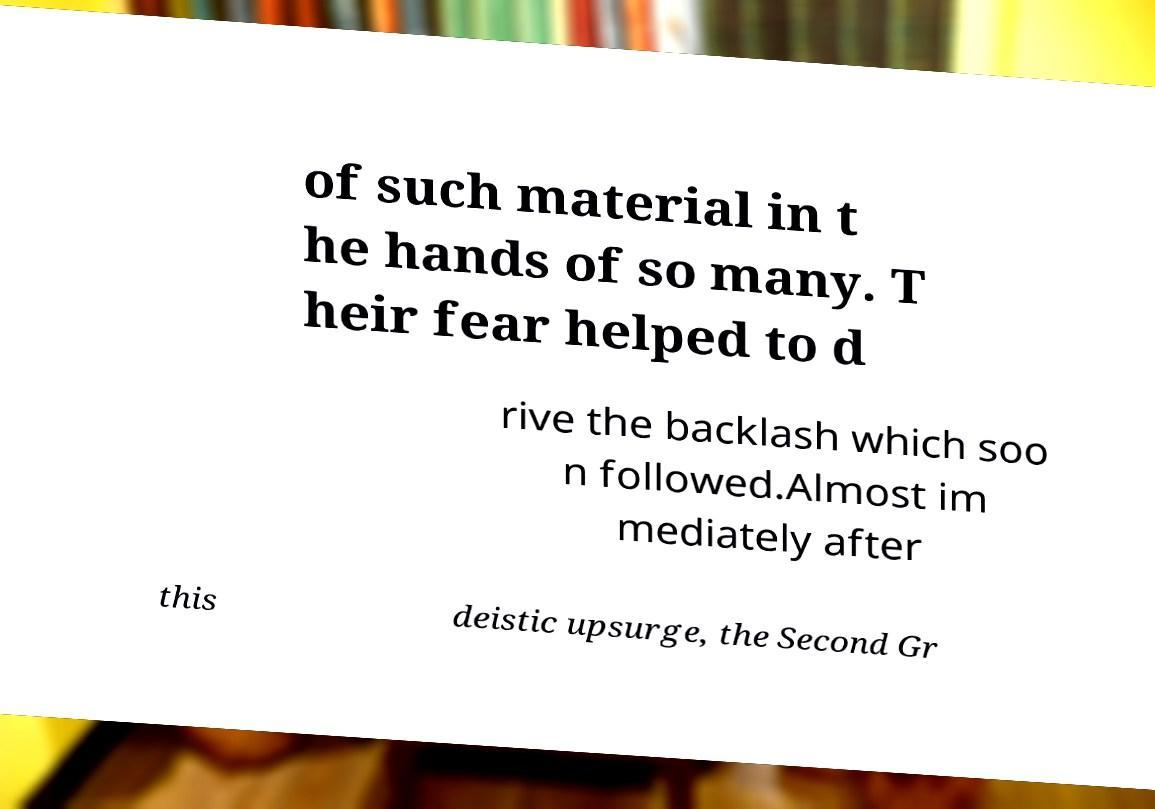Could you assist in decoding the text presented in this image and type it out clearly? of such material in t he hands of so many. T heir fear helped to d rive the backlash which soo n followed.Almost im mediately after this deistic upsurge, the Second Gr 